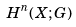Convert formula to latex. <formula><loc_0><loc_0><loc_500><loc_500>H ^ { n } ( X ; G )</formula> 